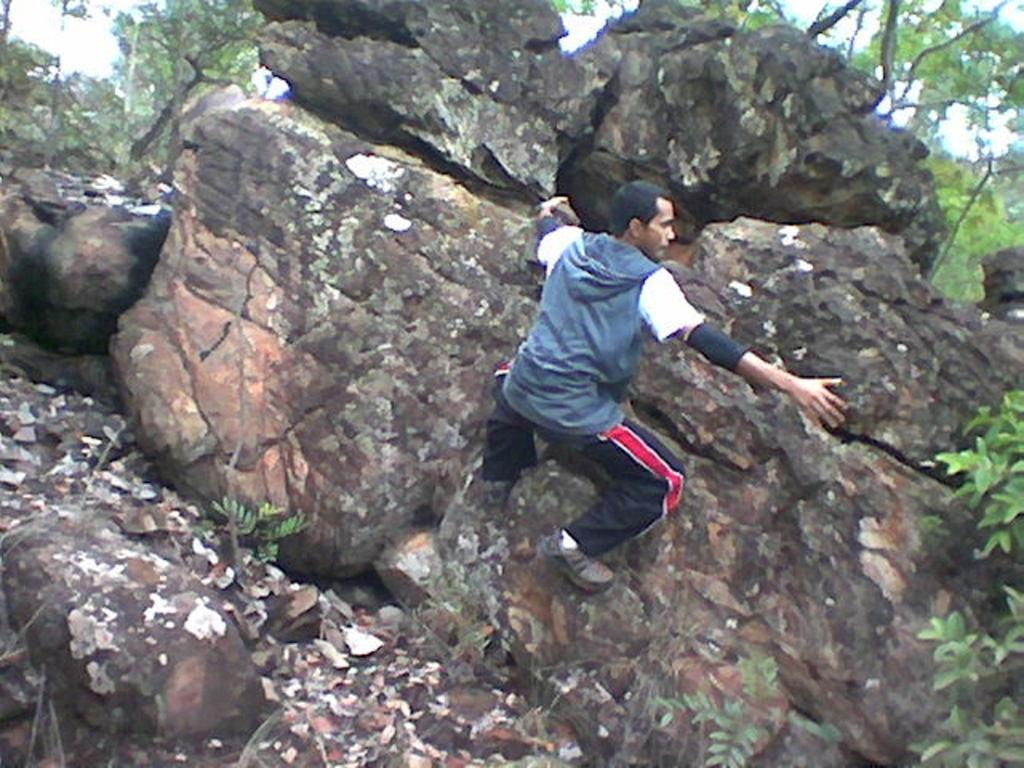Who or what is the main subject in the image? There is a person in the image. What is the person doing in the image? The person is climbing on rocks. What can be seen in the background of the image? There are trees in the background of the image. What type of branch is the person using to climb the rocks in the image? There is no branch visible in the image; the person is climbing on rocks without any apparent assistance. 